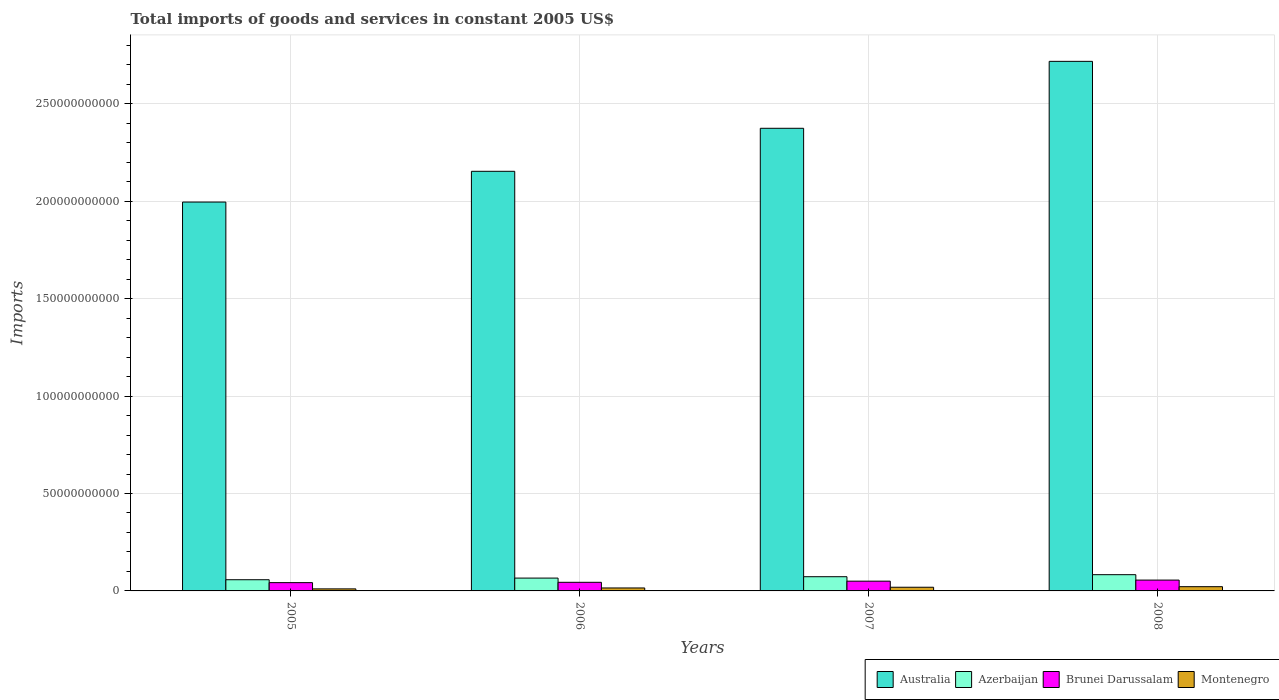How many groups of bars are there?
Offer a very short reply. 4. Are the number of bars on each tick of the X-axis equal?
Your answer should be very brief. Yes. What is the label of the 2nd group of bars from the left?
Your answer should be very brief. 2006. In how many cases, is the number of bars for a given year not equal to the number of legend labels?
Offer a very short reply. 0. What is the total imports of goods and services in Azerbaijan in 2005?
Your response must be concise. 5.74e+09. Across all years, what is the maximum total imports of goods and services in Australia?
Give a very brief answer. 2.72e+11. Across all years, what is the minimum total imports of goods and services in Brunei Darussalam?
Make the answer very short. 4.25e+09. What is the total total imports of goods and services in Azerbaijan in the graph?
Ensure brevity in your answer.  2.80e+1. What is the difference between the total imports of goods and services in Azerbaijan in 2005 and that in 2006?
Give a very brief answer. -8.46e+08. What is the difference between the total imports of goods and services in Brunei Darussalam in 2008 and the total imports of goods and services in Australia in 2005?
Ensure brevity in your answer.  -1.94e+11. What is the average total imports of goods and services in Montenegro per year?
Offer a terse response. 1.66e+09. In the year 2006, what is the difference between the total imports of goods and services in Montenegro and total imports of goods and services in Brunei Darussalam?
Offer a very short reply. -2.91e+09. In how many years, is the total imports of goods and services in Montenegro greater than 270000000000 US$?
Provide a succinct answer. 0. What is the ratio of the total imports of goods and services in Brunei Darussalam in 2005 to that in 2008?
Offer a terse response. 0.76. What is the difference between the highest and the second highest total imports of goods and services in Brunei Darussalam?
Keep it short and to the point. 5.50e+08. What is the difference between the highest and the lowest total imports of goods and services in Brunei Darussalam?
Make the answer very short. 1.31e+09. In how many years, is the total imports of goods and services in Brunei Darussalam greater than the average total imports of goods and services in Brunei Darussalam taken over all years?
Offer a terse response. 2. Is the sum of the total imports of goods and services in Brunei Darussalam in 2006 and 2008 greater than the maximum total imports of goods and services in Montenegro across all years?
Your response must be concise. Yes. Is it the case that in every year, the sum of the total imports of goods and services in Brunei Darussalam and total imports of goods and services in Montenegro is greater than the sum of total imports of goods and services in Australia and total imports of goods and services in Azerbaijan?
Give a very brief answer. No. What does the 2nd bar from the left in 2005 represents?
Offer a terse response. Azerbaijan. What does the 3rd bar from the right in 2008 represents?
Make the answer very short. Azerbaijan. How many bars are there?
Your answer should be compact. 16. Are all the bars in the graph horizontal?
Keep it short and to the point. No. Does the graph contain any zero values?
Offer a very short reply. No. Does the graph contain grids?
Keep it short and to the point. Yes. Where does the legend appear in the graph?
Your response must be concise. Bottom right. How many legend labels are there?
Your answer should be very brief. 4. What is the title of the graph?
Your response must be concise. Total imports of goods and services in constant 2005 US$. Does "Turkmenistan" appear as one of the legend labels in the graph?
Provide a short and direct response. No. What is the label or title of the Y-axis?
Offer a very short reply. Imports. What is the Imports of Australia in 2005?
Ensure brevity in your answer.  2.00e+11. What is the Imports in Azerbaijan in 2005?
Provide a short and direct response. 5.74e+09. What is the Imports in Brunei Darussalam in 2005?
Your answer should be very brief. 4.25e+09. What is the Imports in Montenegro in 2005?
Offer a very short reply. 1.04e+09. What is the Imports in Australia in 2006?
Provide a succinct answer. 2.15e+11. What is the Imports in Azerbaijan in 2006?
Make the answer very short. 6.59e+09. What is the Imports of Brunei Darussalam in 2006?
Your answer should be very brief. 4.43e+09. What is the Imports in Montenegro in 2006?
Keep it short and to the point. 1.52e+09. What is the Imports in Australia in 2007?
Offer a very short reply. 2.37e+11. What is the Imports of Azerbaijan in 2007?
Ensure brevity in your answer.  7.29e+09. What is the Imports in Brunei Darussalam in 2007?
Offer a very short reply. 5.01e+09. What is the Imports of Montenegro in 2007?
Give a very brief answer. 1.89e+09. What is the Imports of Australia in 2008?
Make the answer very short. 2.72e+11. What is the Imports of Azerbaijan in 2008?
Your response must be concise. 8.33e+09. What is the Imports of Brunei Darussalam in 2008?
Make the answer very short. 5.56e+09. What is the Imports in Montenegro in 2008?
Offer a very short reply. 2.17e+09. Across all years, what is the maximum Imports in Australia?
Provide a succinct answer. 2.72e+11. Across all years, what is the maximum Imports of Azerbaijan?
Provide a succinct answer. 8.33e+09. Across all years, what is the maximum Imports of Brunei Darussalam?
Offer a terse response. 5.56e+09. Across all years, what is the maximum Imports of Montenegro?
Keep it short and to the point. 2.17e+09. Across all years, what is the minimum Imports in Australia?
Your response must be concise. 2.00e+11. Across all years, what is the minimum Imports of Azerbaijan?
Offer a very short reply. 5.74e+09. Across all years, what is the minimum Imports in Brunei Darussalam?
Your answer should be very brief. 4.25e+09. Across all years, what is the minimum Imports in Montenegro?
Your answer should be very brief. 1.04e+09. What is the total Imports in Australia in the graph?
Offer a very short reply. 9.24e+11. What is the total Imports of Azerbaijan in the graph?
Keep it short and to the point. 2.80e+1. What is the total Imports of Brunei Darussalam in the graph?
Provide a succinct answer. 1.92e+1. What is the total Imports in Montenegro in the graph?
Provide a short and direct response. 6.62e+09. What is the difference between the Imports of Australia in 2005 and that in 2006?
Offer a terse response. -1.58e+1. What is the difference between the Imports of Azerbaijan in 2005 and that in 2006?
Your response must be concise. -8.46e+08. What is the difference between the Imports of Brunei Darussalam in 2005 and that in 2006?
Offer a very short reply. -1.74e+08. What is the difference between the Imports in Montenegro in 2005 and that in 2006?
Your answer should be very brief. -4.70e+08. What is the difference between the Imports in Australia in 2005 and that in 2007?
Make the answer very short. -3.79e+1. What is the difference between the Imports in Azerbaijan in 2005 and that in 2007?
Offer a terse response. -1.55e+09. What is the difference between the Imports of Brunei Darussalam in 2005 and that in 2007?
Provide a succinct answer. -7.59e+08. What is the difference between the Imports in Montenegro in 2005 and that in 2007?
Your answer should be very brief. -8.42e+08. What is the difference between the Imports in Australia in 2005 and that in 2008?
Give a very brief answer. -7.22e+1. What is the difference between the Imports in Azerbaijan in 2005 and that in 2008?
Your response must be concise. -2.59e+09. What is the difference between the Imports in Brunei Darussalam in 2005 and that in 2008?
Your answer should be very brief. -1.31e+09. What is the difference between the Imports in Montenegro in 2005 and that in 2008?
Keep it short and to the point. -1.13e+09. What is the difference between the Imports in Australia in 2006 and that in 2007?
Provide a short and direct response. -2.21e+1. What is the difference between the Imports in Azerbaijan in 2006 and that in 2007?
Make the answer very short. -7.02e+08. What is the difference between the Imports in Brunei Darussalam in 2006 and that in 2007?
Ensure brevity in your answer.  -5.85e+08. What is the difference between the Imports in Montenegro in 2006 and that in 2007?
Offer a very short reply. -3.71e+08. What is the difference between the Imports of Australia in 2006 and that in 2008?
Your answer should be compact. -5.64e+1. What is the difference between the Imports of Azerbaijan in 2006 and that in 2008?
Provide a short and direct response. -1.75e+09. What is the difference between the Imports in Brunei Darussalam in 2006 and that in 2008?
Provide a short and direct response. -1.13e+09. What is the difference between the Imports in Montenegro in 2006 and that in 2008?
Offer a terse response. -6.59e+08. What is the difference between the Imports in Australia in 2007 and that in 2008?
Give a very brief answer. -3.44e+1. What is the difference between the Imports of Azerbaijan in 2007 and that in 2008?
Provide a succinct answer. -1.04e+09. What is the difference between the Imports of Brunei Darussalam in 2007 and that in 2008?
Your answer should be compact. -5.50e+08. What is the difference between the Imports in Montenegro in 2007 and that in 2008?
Your answer should be very brief. -2.88e+08. What is the difference between the Imports of Australia in 2005 and the Imports of Azerbaijan in 2006?
Your answer should be compact. 1.93e+11. What is the difference between the Imports of Australia in 2005 and the Imports of Brunei Darussalam in 2006?
Offer a terse response. 1.95e+11. What is the difference between the Imports of Australia in 2005 and the Imports of Montenegro in 2006?
Give a very brief answer. 1.98e+11. What is the difference between the Imports of Azerbaijan in 2005 and the Imports of Brunei Darussalam in 2006?
Make the answer very short. 1.32e+09. What is the difference between the Imports in Azerbaijan in 2005 and the Imports in Montenegro in 2006?
Offer a terse response. 4.23e+09. What is the difference between the Imports in Brunei Darussalam in 2005 and the Imports in Montenegro in 2006?
Provide a succinct answer. 2.74e+09. What is the difference between the Imports in Australia in 2005 and the Imports in Azerbaijan in 2007?
Make the answer very short. 1.92e+11. What is the difference between the Imports in Australia in 2005 and the Imports in Brunei Darussalam in 2007?
Ensure brevity in your answer.  1.95e+11. What is the difference between the Imports in Australia in 2005 and the Imports in Montenegro in 2007?
Your answer should be very brief. 1.98e+11. What is the difference between the Imports of Azerbaijan in 2005 and the Imports of Brunei Darussalam in 2007?
Ensure brevity in your answer.  7.32e+08. What is the difference between the Imports in Azerbaijan in 2005 and the Imports in Montenegro in 2007?
Offer a terse response. 3.86e+09. What is the difference between the Imports in Brunei Darussalam in 2005 and the Imports in Montenegro in 2007?
Make the answer very short. 2.37e+09. What is the difference between the Imports of Australia in 2005 and the Imports of Azerbaijan in 2008?
Provide a succinct answer. 1.91e+11. What is the difference between the Imports in Australia in 2005 and the Imports in Brunei Darussalam in 2008?
Ensure brevity in your answer.  1.94e+11. What is the difference between the Imports in Australia in 2005 and the Imports in Montenegro in 2008?
Ensure brevity in your answer.  1.97e+11. What is the difference between the Imports in Azerbaijan in 2005 and the Imports in Brunei Darussalam in 2008?
Offer a terse response. 1.82e+08. What is the difference between the Imports in Azerbaijan in 2005 and the Imports in Montenegro in 2008?
Your answer should be compact. 3.57e+09. What is the difference between the Imports in Brunei Darussalam in 2005 and the Imports in Montenegro in 2008?
Offer a terse response. 2.08e+09. What is the difference between the Imports of Australia in 2006 and the Imports of Azerbaijan in 2007?
Give a very brief answer. 2.08e+11. What is the difference between the Imports of Australia in 2006 and the Imports of Brunei Darussalam in 2007?
Offer a terse response. 2.10e+11. What is the difference between the Imports of Australia in 2006 and the Imports of Montenegro in 2007?
Offer a terse response. 2.13e+11. What is the difference between the Imports of Azerbaijan in 2006 and the Imports of Brunei Darussalam in 2007?
Your response must be concise. 1.58e+09. What is the difference between the Imports of Azerbaijan in 2006 and the Imports of Montenegro in 2007?
Provide a succinct answer. 4.70e+09. What is the difference between the Imports in Brunei Darussalam in 2006 and the Imports in Montenegro in 2007?
Offer a very short reply. 2.54e+09. What is the difference between the Imports in Australia in 2006 and the Imports in Azerbaijan in 2008?
Your response must be concise. 2.07e+11. What is the difference between the Imports of Australia in 2006 and the Imports of Brunei Darussalam in 2008?
Keep it short and to the point. 2.10e+11. What is the difference between the Imports of Australia in 2006 and the Imports of Montenegro in 2008?
Your response must be concise. 2.13e+11. What is the difference between the Imports in Azerbaijan in 2006 and the Imports in Brunei Darussalam in 2008?
Ensure brevity in your answer.  1.03e+09. What is the difference between the Imports of Azerbaijan in 2006 and the Imports of Montenegro in 2008?
Provide a succinct answer. 4.41e+09. What is the difference between the Imports of Brunei Darussalam in 2006 and the Imports of Montenegro in 2008?
Provide a succinct answer. 2.25e+09. What is the difference between the Imports of Australia in 2007 and the Imports of Azerbaijan in 2008?
Your answer should be compact. 2.29e+11. What is the difference between the Imports of Australia in 2007 and the Imports of Brunei Darussalam in 2008?
Your answer should be compact. 2.32e+11. What is the difference between the Imports of Australia in 2007 and the Imports of Montenegro in 2008?
Your response must be concise. 2.35e+11. What is the difference between the Imports of Azerbaijan in 2007 and the Imports of Brunei Darussalam in 2008?
Offer a very short reply. 1.73e+09. What is the difference between the Imports of Azerbaijan in 2007 and the Imports of Montenegro in 2008?
Give a very brief answer. 5.12e+09. What is the difference between the Imports in Brunei Darussalam in 2007 and the Imports in Montenegro in 2008?
Offer a very short reply. 2.84e+09. What is the average Imports of Australia per year?
Give a very brief answer. 2.31e+11. What is the average Imports of Azerbaijan per year?
Offer a very short reply. 6.99e+09. What is the average Imports of Brunei Darussalam per year?
Your response must be concise. 4.81e+09. What is the average Imports in Montenegro per year?
Offer a very short reply. 1.66e+09. In the year 2005, what is the difference between the Imports in Australia and Imports in Azerbaijan?
Your answer should be compact. 1.94e+11. In the year 2005, what is the difference between the Imports of Australia and Imports of Brunei Darussalam?
Provide a succinct answer. 1.95e+11. In the year 2005, what is the difference between the Imports in Australia and Imports in Montenegro?
Provide a short and direct response. 1.99e+11. In the year 2005, what is the difference between the Imports in Azerbaijan and Imports in Brunei Darussalam?
Offer a very short reply. 1.49e+09. In the year 2005, what is the difference between the Imports of Azerbaijan and Imports of Montenegro?
Ensure brevity in your answer.  4.70e+09. In the year 2005, what is the difference between the Imports of Brunei Darussalam and Imports of Montenegro?
Provide a short and direct response. 3.21e+09. In the year 2006, what is the difference between the Imports of Australia and Imports of Azerbaijan?
Give a very brief answer. 2.09e+11. In the year 2006, what is the difference between the Imports in Australia and Imports in Brunei Darussalam?
Provide a short and direct response. 2.11e+11. In the year 2006, what is the difference between the Imports in Australia and Imports in Montenegro?
Your response must be concise. 2.14e+11. In the year 2006, what is the difference between the Imports in Azerbaijan and Imports in Brunei Darussalam?
Provide a succinct answer. 2.16e+09. In the year 2006, what is the difference between the Imports of Azerbaijan and Imports of Montenegro?
Your response must be concise. 5.07e+09. In the year 2006, what is the difference between the Imports in Brunei Darussalam and Imports in Montenegro?
Your answer should be very brief. 2.91e+09. In the year 2007, what is the difference between the Imports of Australia and Imports of Azerbaijan?
Give a very brief answer. 2.30e+11. In the year 2007, what is the difference between the Imports of Australia and Imports of Brunei Darussalam?
Give a very brief answer. 2.32e+11. In the year 2007, what is the difference between the Imports of Australia and Imports of Montenegro?
Your answer should be very brief. 2.36e+11. In the year 2007, what is the difference between the Imports in Azerbaijan and Imports in Brunei Darussalam?
Provide a succinct answer. 2.28e+09. In the year 2007, what is the difference between the Imports of Azerbaijan and Imports of Montenegro?
Your response must be concise. 5.40e+09. In the year 2007, what is the difference between the Imports in Brunei Darussalam and Imports in Montenegro?
Offer a terse response. 3.12e+09. In the year 2008, what is the difference between the Imports of Australia and Imports of Azerbaijan?
Keep it short and to the point. 2.63e+11. In the year 2008, what is the difference between the Imports in Australia and Imports in Brunei Darussalam?
Provide a succinct answer. 2.66e+11. In the year 2008, what is the difference between the Imports in Australia and Imports in Montenegro?
Make the answer very short. 2.70e+11. In the year 2008, what is the difference between the Imports in Azerbaijan and Imports in Brunei Darussalam?
Make the answer very short. 2.77e+09. In the year 2008, what is the difference between the Imports of Azerbaijan and Imports of Montenegro?
Ensure brevity in your answer.  6.16e+09. In the year 2008, what is the difference between the Imports in Brunei Darussalam and Imports in Montenegro?
Give a very brief answer. 3.39e+09. What is the ratio of the Imports of Australia in 2005 to that in 2006?
Your answer should be compact. 0.93. What is the ratio of the Imports of Azerbaijan in 2005 to that in 2006?
Your answer should be compact. 0.87. What is the ratio of the Imports of Brunei Darussalam in 2005 to that in 2006?
Make the answer very short. 0.96. What is the ratio of the Imports in Montenegro in 2005 to that in 2006?
Provide a succinct answer. 0.69. What is the ratio of the Imports in Australia in 2005 to that in 2007?
Ensure brevity in your answer.  0.84. What is the ratio of the Imports of Azerbaijan in 2005 to that in 2007?
Offer a terse response. 0.79. What is the ratio of the Imports in Brunei Darussalam in 2005 to that in 2007?
Keep it short and to the point. 0.85. What is the ratio of the Imports of Montenegro in 2005 to that in 2007?
Keep it short and to the point. 0.55. What is the ratio of the Imports of Australia in 2005 to that in 2008?
Keep it short and to the point. 0.73. What is the ratio of the Imports of Azerbaijan in 2005 to that in 2008?
Ensure brevity in your answer.  0.69. What is the ratio of the Imports in Brunei Darussalam in 2005 to that in 2008?
Ensure brevity in your answer.  0.76. What is the ratio of the Imports in Montenegro in 2005 to that in 2008?
Your response must be concise. 0.48. What is the ratio of the Imports in Australia in 2006 to that in 2007?
Give a very brief answer. 0.91. What is the ratio of the Imports of Azerbaijan in 2006 to that in 2007?
Keep it short and to the point. 0.9. What is the ratio of the Imports in Brunei Darussalam in 2006 to that in 2007?
Ensure brevity in your answer.  0.88. What is the ratio of the Imports in Montenegro in 2006 to that in 2007?
Provide a succinct answer. 0.8. What is the ratio of the Imports in Australia in 2006 to that in 2008?
Your answer should be very brief. 0.79. What is the ratio of the Imports of Azerbaijan in 2006 to that in 2008?
Provide a succinct answer. 0.79. What is the ratio of the Imports in Brunei Darussalam in 2006 to that in 2008?
Provide a short and direct response. 0.8. What is the ratio of the Imports in Montenegro in 2006 to that in 2008?
Offer a very short reply. 0.7. What is the ratio of the Imports of Australia in 2007 to that in 2008?
Your answer should be very brief. 0.87. What is the ratio of the Imports in Azerbaijan in 2007 to that in 2008?
Make the answer very short. 0.87. What is the ratio of the Imports of Brunei Darussalam in 2007 to that in 2008?
Your response must be concise. 0.9. What is the ratio of the Imports of Montenegro in 2007 to that in 2008?
Keep it short and to the point. 0.87. What is the difference between the highest and the second highest Imports of Australia?
Provide a succinct answer. 3.44e+1. What is the difference between the highest and the second highest Imports in Azerbaijan?
Provide a succinct answer. 1.04e+09. What is the difference between the highest and the second highest Imports of Brunei Darussalam?
Your answer should be compact. 5.50e+08. What is the difference between the highest and the second highest Imports of Montenegro?
Provide a succinct answer. 2.88e+08. What is the difference between the highest and the lowest Imports in Australia?
Make the answer very short. 7.22e+1. What is the difference between the highest and the lowest Imports in Azerbaijan?
Your answer should be compact. 2.59e+09. What is the difference between the highest and the lowest Imports of Brunei Darussalam?
Make the answer very short. 1.31e+09. What is the difference between the highest and the lowest Imports of Montenegro?
Provide a short and direct response. 1.13e+09. 